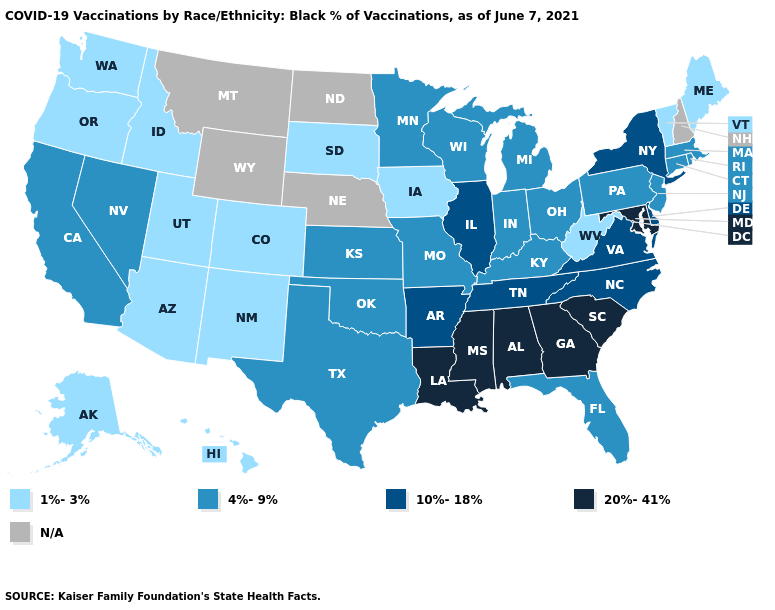What is the value of Kansas?
Be succinct. 4%-9%. Does Minnesota have the highest value in the MidWest?
Short answer required. No. Is the legend a continuous bar?
Keep it brief. No. Among the states that border Tennessee , does Kentucky have the lowest value?
Be succinct. Yes. Which states have the lowest value in the USA?
Keep it brief. Alaska, Arizona, Colorado, Hawaii, Idaho, Iowa, Maine, New Mexico, Oregon, South Dakota, Utah, Vermont, Washington, West Virginia. Name the states that have a value in the range 4%-9%?
Keep it brief. California, Connecticut, Florida, Indiana, Kansas, Kentucky, Massachusetts, Michigan, Minnesota, Missouri, Nevada, New Jersey, Ohio, Oklahoma, Pennsylvania, Rhode Island, Texas, Wisconsin. Does the first symbol in the legend represent the smallest category?
Short answer required. Yes. What is the highest value in the Northeast ?
Quick response, please. 10%-18%. Name the states that have a value in the range 10%-18%?
Keep it brief. Arkansas, Delaware, Illinois, New York, North Carolina, Tennessee, Virginia. Among the states that border Rhode Island , which have the lowest value?
Quick response, please. Connecticut, Massachusetts. What is the highest value in the West ?
Concise answer only. 4%-9%. 